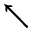<formula> <loc_0><loc_0><loc_500><loc_500>\nwarrow</formula> 